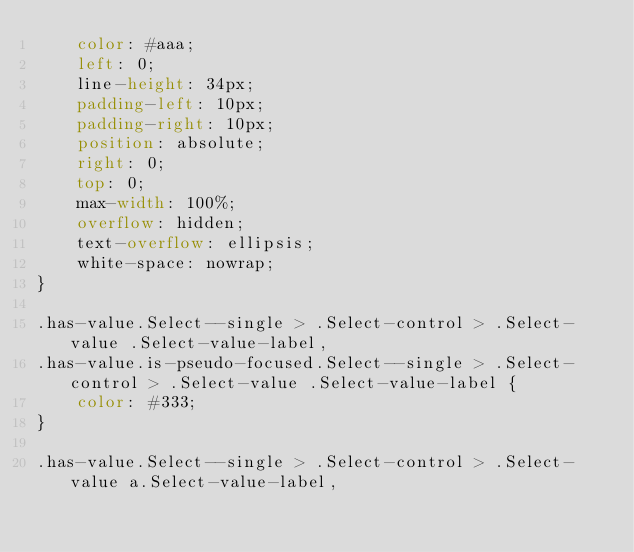Convert code to text. <code><loc_0><loc_0><loc_500><loc_500><_CSS_>    color: #aaa;
    left: 0;
    line-height: 34px;
    padding-left: 10px;
    padding-right: 10px;
    position: absolute;
    right: 0;
    top: 0;
    max-width: 100%;
    overflow: hidden;
    text-overflow: ellipsis;
    white-space: nowrap;
}

.has-value.Select--single > .Select-control > .Select-value .Select-value-label,
.has-value.is-pseudo-focused.Select--single > .Select-control > .Select-value .Select-value-label {
    color: #333;
}

.has-value.Select--single > .Select-control > .Select-value a.Select-value-label,</code> 